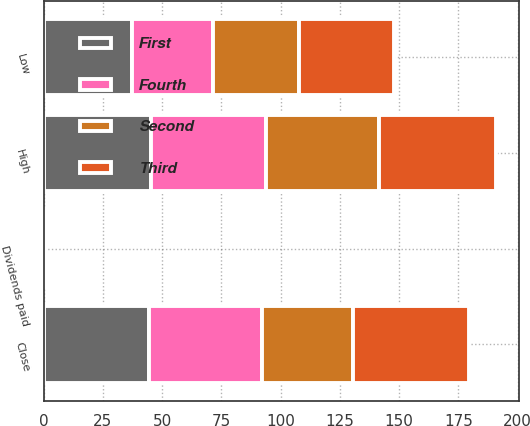<chart> <loc_0><loc_0><loc_500><loc_500><stacked_bar_chart><ecel><fcel>High<fcel>Low<fcel>Close<fcel>Dividends paid<nl><fcel>Fourth<fcel>48.77<fcel>33.88<fcel>47.61<fcel>0.22<nl><fcel>Second<fcel>47.59<fcel>36.31<fcel>38.28<fcel>0.22<nl><fcel>First<fcel>45.21<fcel>37.43<fcel>44.51<fcel>0.22<nl><fcel>Third<fcel>49.5<fcel>40.3<fcel>49.15<fcel>0.22<nl></chart> 